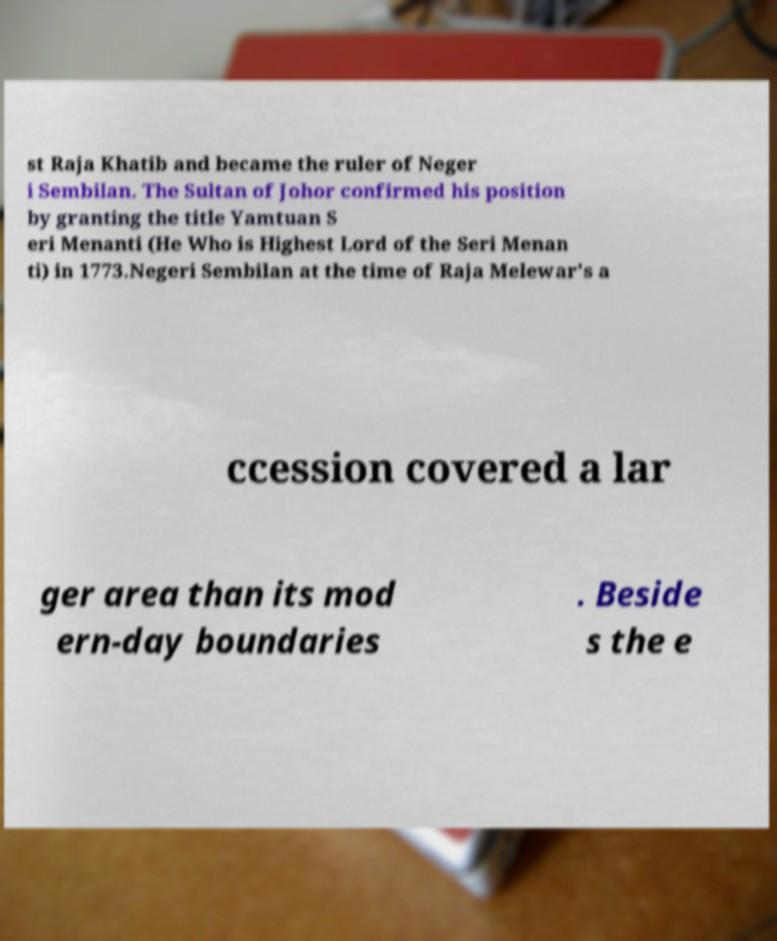For documentation purposes, I need the text within this image transcribed. Could you provide that? st Raja Khatib and became the ruler of Neger i Sembilan. The Sultan of Johor confirmed his position by granting the title Yamtuan S eri Menanti (He Who is Highest Lord of the Seri Menan ti) in 1773.Negeri Sembilan at the time of Raja Melewar's a ccession covered a lar ger area than its mod ern-day boundaries . Beside s the e 